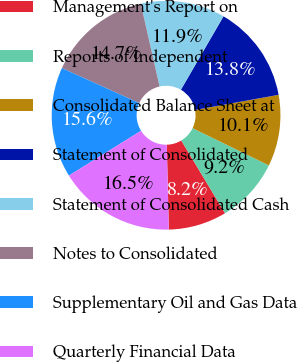Convert chart to OTSL. <chart><loc_0><loc_0><loc_500><loc_500><pie_chart><fcel>Management's Report on<fcel>Reports of Independent<fcel>Consolidated Balance Sheet at<fcel>Statement of Consolidated<fcel>Statement of Consolidated Cash<fcel>Notes to Consolidated<fcel>Supplementary Oil and Gas Data<fcel>Quarterly Financial Data<nl><fcel>8.24%<fcel>9.16%<fcel>10.08%<fcel>13.77%<fcel>11.92%<fcel>14.69%<fcel>15.61%<fcel>16.53%<nl></chart> 